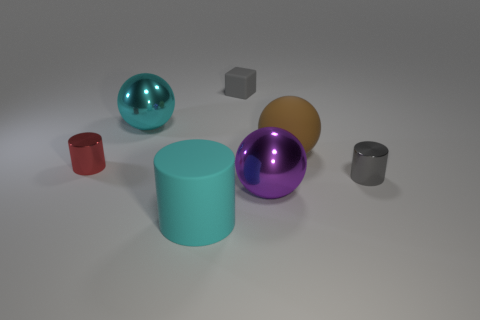How do the colors of the objects contribute to the composition of the image? The colors of the objects provide a vibrant contrast that adds visual interest. The bright, reflective surfaces of the spheres in teal, purple, and gold stand out against the more subdued tones of the gray cube and cylinders. The red cylinder adds a pop of color that catches the eye and balances the composition. 